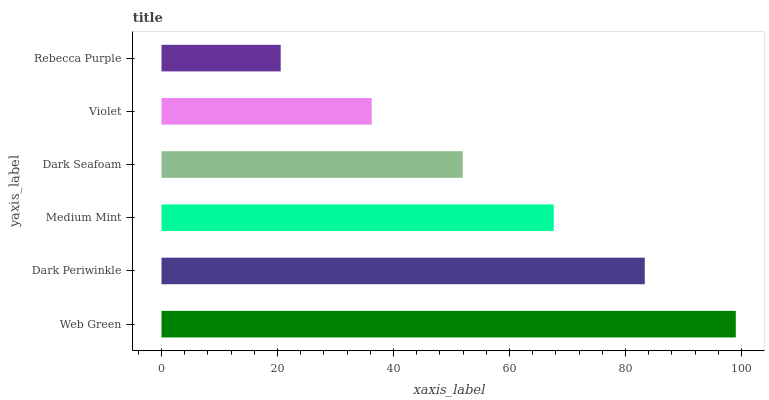Is Rebecca Purple the minimum?
Answer yes or no. Yes. Is Web Green the maximum?
Answer yes or no. Yes. Is Dark Periwinkle the minimum?
Answer yes or no. No. Is Dark Periwinkle the maximum?
Answer yes or no. No. Is Web Green greater than Dark Periwinkle?
Answer yes or no. Yes. Is Dark Periwinkle less than Web Green?
Answer yes or no. Yes. Is Dark Periwinkle greater than Web Green?
Answer yes or no. No. Is Web Green less than Dark Periwinkle?
Answer yes or no. No. Is Medium Mint the high median?
Answer yes or no. Yes. Is Dark Seafoam the low median?
Answer yes or no. Yes. Is Dark Periwinkle the high median?
Answer yes or no. No. Is Medium Mint the low median?
Answer yes or no. No. 